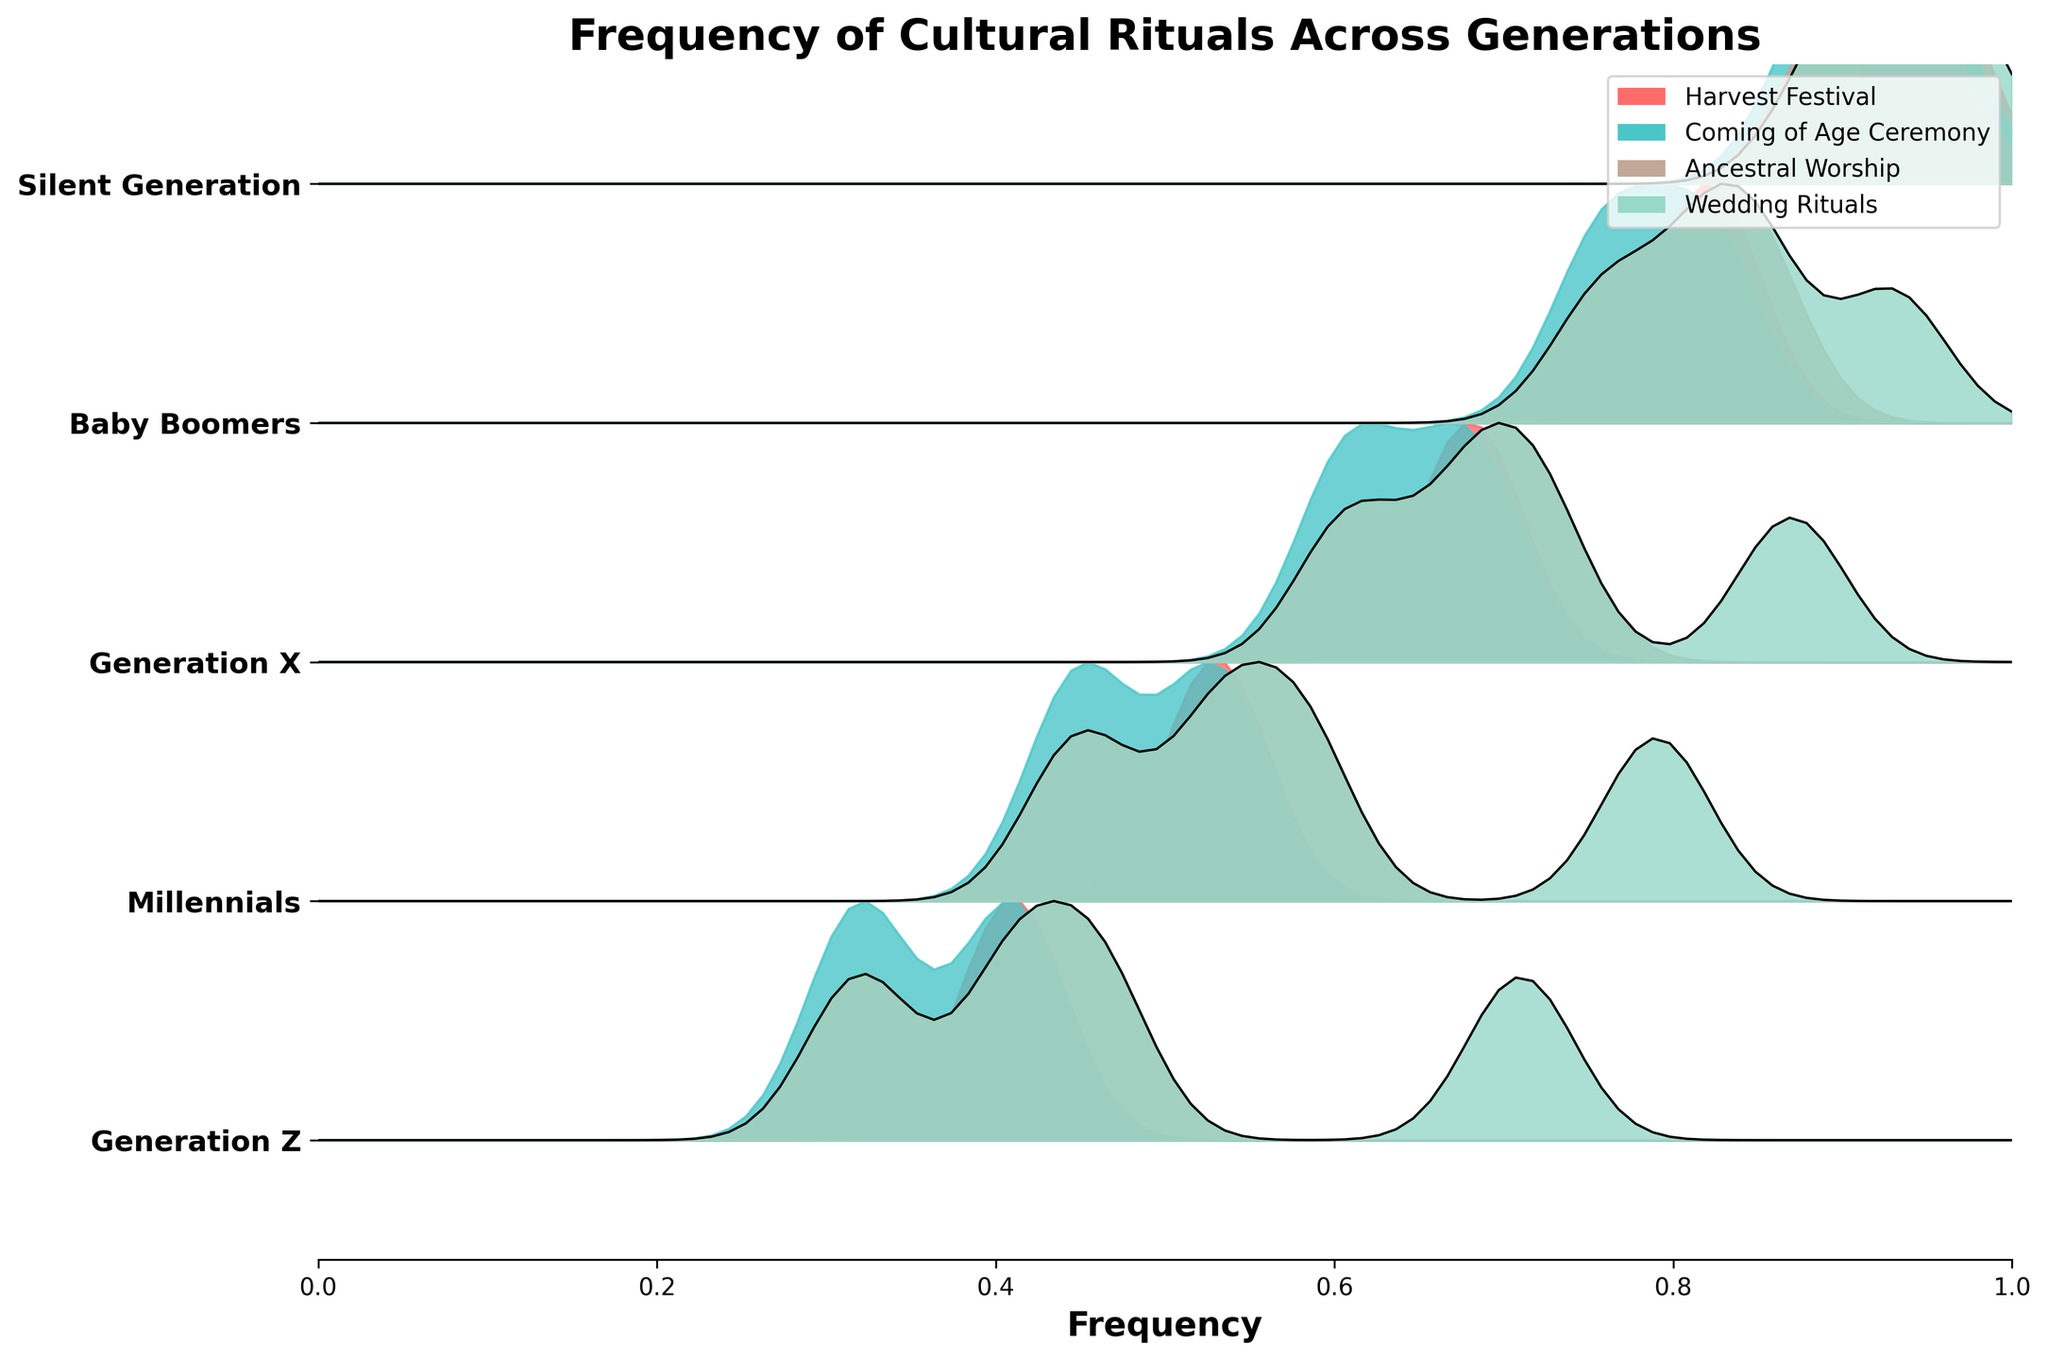What is the title of the Ridgeline plot? The title is usually located at the top of the plot and provides the main topic or subject of the figure. It gives an overview of what the data represents.
Answer: Frequency of Cultural Rituals Across Generations What does the x-axis represent in this Ridgeline plot? The x-axis typically indicates the variable being measured. In this case, it showcases the frequency of cultural rituals being observed.
Answer: Frequency Which generation shows the highest frequency for the Harvest Festival? To identify this, look for the peak in the ridgelines corresponding to the Harvest Festival for each generation; the highest peak indicates the highest frequency.
Answer: Silent Generation Which ritual has the lowest frequency for Generation Z? Find the lowest point in the relevant curves for Generation Z. Compare the frequencies for each ritual within Generation Z.
Answer: Coming of Age Ceremony What trend do you observe in the frequency of Ancestral Worship across generations? Observe the curves for Ancestral Worship across all generations. Noting the general direction of frequency can reveal the trend.
Answer: Decreasing For which generation is there the smallest difference between the frequencies of the Wedding Rituals and the Harvest Festival? Examine each generation’s frequencies for Wedding Rituals and Harvest Festival, calculate the differences, and choose the smallest.
Answer: Baby Boomers How many generations are displayed in this Ridgeline plot? Count the number of distinct curved sections or look at the number of different labels on the y-axis.
Answer: Five Which ritual shows the most significant drop in frequency from the Silent Generation to Generation Z? Calculate the difference in frequencies for each ritual between the Silent Generation and Generation Z, and identify the largest drop.
Answer: Harvest Festival Do the frequencies of all rituals decrease uniformly across generations? Analyze each ritual's trend across the generations to see if they all follow the same pattern or differ.
Answer: No Which generation has the highest overall frequency for all rituals combined? Sum up the frequencies for all rituals for each generation and compare the totals to find the highest.
Answer: Silent Generation Which ritual's frequency fluctuates the least across all generations? Evaluate the variability in the frequencies for each ritual by looking for the one with the smallest changes across generations.
Answer: Wedding Rituals 